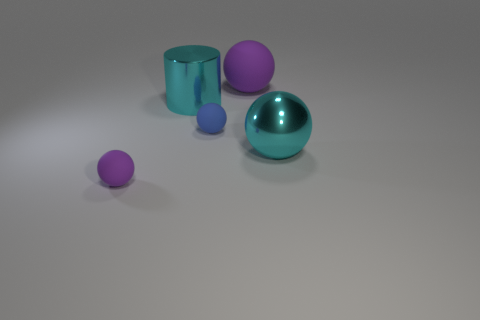Are there any other things that have the same color as the large shiny cylinder?
Give a very brief answer. Yes. There is a cyan thing that is the same material as the big cyan sphere; what is its shape?
Give a very brief answer. Cylinder. There is a small blue thing that is to the right of the tiny matte ball that is left of the blue rubber object; how many cyan objects are in front of it?
Give a very brief answer. 1. What is the shape of the matte thing that is both in front of the cylinder and behind the tiny purple object?
Your response must be concise. Sphere. Are there fewer purple rubber spheres that are in front of the metal sphere than rubber balls?
Your response must be concise. Yes. How many tiny things are balls or cyan spheres?
Your answer should be compact. 2. How big is the cyan metal ball?
Offer a very short reply. Large. Is there anything else that has the same material as the cylinder?
Offer a very short reply. Yes. How many big spheres are behind the big metal ball?
Offer a very short reply. 1. There is another metallic thing that is the same shape as the blue thing; what size is it?
Make the answer very short. Large. 